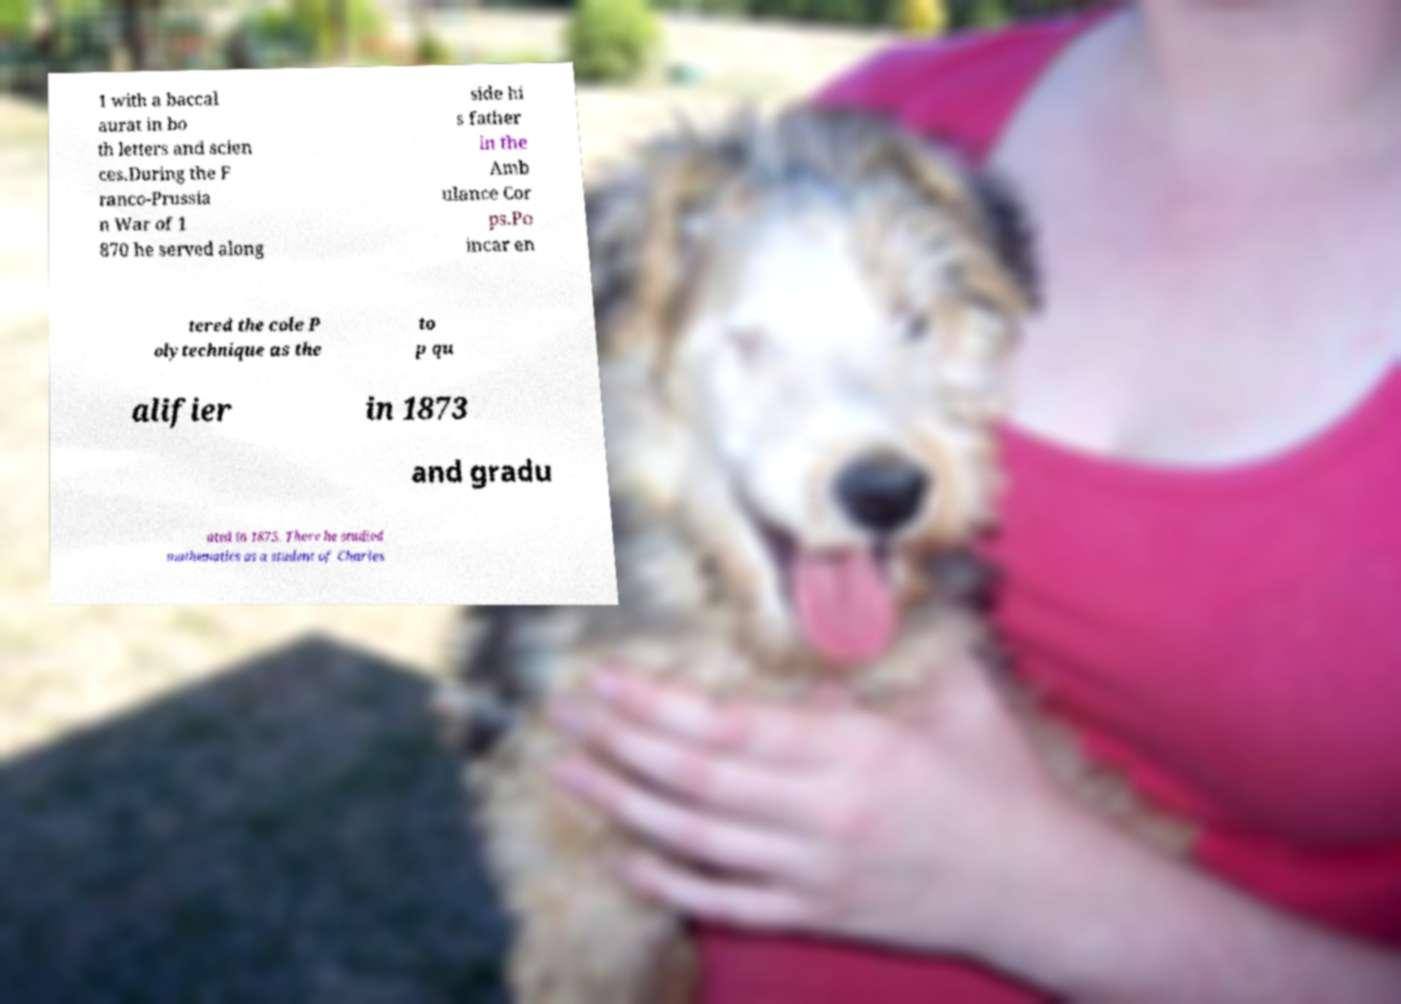Could you assist in decoding the text presented in this image and type it out clearly? 1 with a baccal aurat in bo th letters and scien ces.During the F ranco-Prussia n War of 1 870 he served along side hi s father in the Amb ulance Cor ps.Po incar en tered the cole P olytechnique as the to p qu alifier in 1873 and gradu ated in 1875. There he studied mathematics as a student of Charles 